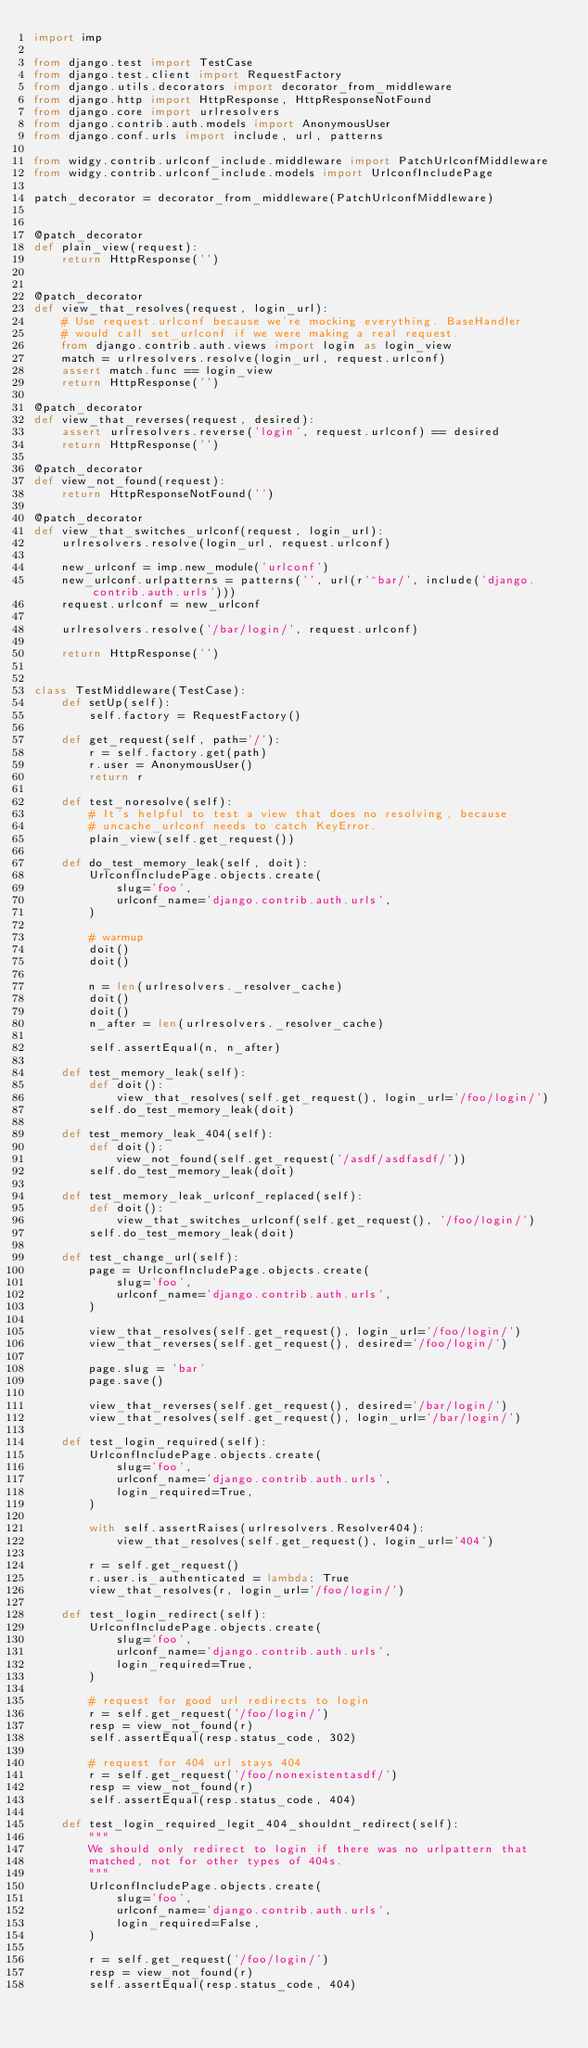<code> <loc_0><loc_0><loc_500><loc_500><_Python_>import imp

from django.test import TestCase
from django.test.client import RequestFactory
from django.utils.decorators import decorator_from_middleware
from django.http import HttpResponse, HttpResponseNotFound
from django.core import urlresolvers
from django.contrib.auth.models import AnonymousUser
from django.conf.urls import include, url, patterns

from widgy.contrib.urlconf_include.middleware import PatchUrlconfMiddleware
from widgy.contrib.urlconf_include.models import UrlconfIncludePage

patch_decorator = decorator_from_middleware(PatchUrlconfMiddleware)


@patch_decorator
def plain_view(request):
    return HttpResponse('')


@patch_decorator
def view_that_resolves(request, login_url):
    # Use request.urlconf because we're mocking everything. BaseHandler
    # would call set_urlconf if we were making a real request.
    from django.contrib.auth.views import login as login_view
    match = urlresolvers.resolve(login_url, request.urlconf)
    assert match.func == login_view
    return HttpResponse('')

@patch_decorator
def view_that_reverses(request, desired):
    assert urlresolvers.reverse('login', request.urlconf) == desired
    return HttpResponse('')

@patch_decorator
def view_not_found(request):
    return HttpResponseNotFound('')

@patch_decorator
def view_that_switches_urlconf(request, login_url):
    urlresolvers.resolve(login_url, request.urlconf)

    new_urlconf = imp.new_module('urlconf')
    new_urlconf.urlpatterns = patterns('', url(r'^bar/', include('django.contrib.auth.urls')))
    request.urlconf = new_urlconf

    urlresolvers.resolve('/bar/login/', request.urlconf)

    return HttpResponse('')


class TestMiddleware(TestCase):
    def setUp(self):
        self.factory = RequestFactory()

    def get_request(self, path='/'):
        r = self.factory.get(path)
        r.user = AnonymousUser()
        return r

    def test_noresolve(self):
        # It's helpful to test a view that does no resolving, because
        # uncache_urlconf needs to catch KeyError.
        plain_view(self.get_request())

    def do_test_memory_leak(self, doit):
        UrlconfIncludePage.objects.create(
            slug='foo',
            urlconf_name='django.contrib.auth.urls',
        )

        # warmup
        doit()
        doit()

        n = len(urlresolvers._resolver_cache)
        doit()
        doit()
        n_after = len(urlresolvers._resolver_cache)

        self.assertEqual(n, n_after)

    def test_memory_leak(self):
        def doit():
            view_that_resolves(self.get_request(), login_url='/foo/login/')
        self.do_test_memory_leak(doit)

    def test_memory_leak_404(self):
        def doit():
            view_not_found(self.get_request('/asdf/asdfasdf/'))
        self.do_test_memory_leak(doit)

    def test_memory_leak_urlconf_replaced(self):
        def doit():
            view_that_switches_urlconf(self.get_request(), '/foo/login/')
        self.do_test_memory_leak(doit)

    def test_change_url(self):
        page = UrlconfIncludePage.objects.create(
            slug='foo',
            urlconf_name='django.contrib.auth.urls',
        )

        view_that_resolves(self.get_request(), login_url='/foo/login/')
        view_that_reverses(self.get_request(), desired='/foo/login/')

        page.slug = 'bar'
        page.save()

        view_that_reverses(self.get_request(), desired='/bar/login/')
        view_that_resolves(self.get_request(), login_url='/bar/login/')

    def test_login_required(self):
        UrlconfIncludePage.objects.create(
            slug='foo',
            urlconf_name='django.contrib.auth.urls',
            login_required=True,
        )

        with self.assertRaises(urlresolvers.Resolver404):
            view_that_resolves(self.get_request(), login_url='404')

        r = self.get_request()
        r.user.is_authenticated = lambda: True
        view_that_resolves(r, login_url='/foo/login/')

    def test_login_redirect(self):
        UrlconfIncludePage.objects.create(
            slug='foo',
            urlconf_name='django.contrib.auth.urls',
            login_required=True,
        )

        # request for good url redirects to login
        r = self.get_request('/foo/login/')
        resp = view_not_found(r)
        self.assertEqual(resp.status_code, 302)

        # request for 404 url stays 404
        r = self.get_request('/foo/nonexistentasdf/')
        resp = view_not_found(r)
        self.assertEqual(resp.status_code, 404)

    def test_login_required_legit_404_shouldnt_redirect(self):
        """
        We should only redirect to login if there was no urlpattern that
        matched, not for other types of 404s.
        """
        UrlconfIncludePage.objects.create(
            slug='foo',
            urlconf_name='django.contrib.auth.urls',
            login_required=False,
        )

        r = self.get_request('/foo/login/')
        resp = view_not_found(r)
        self.assertEqual(resp.status_code, 404)
</code> 